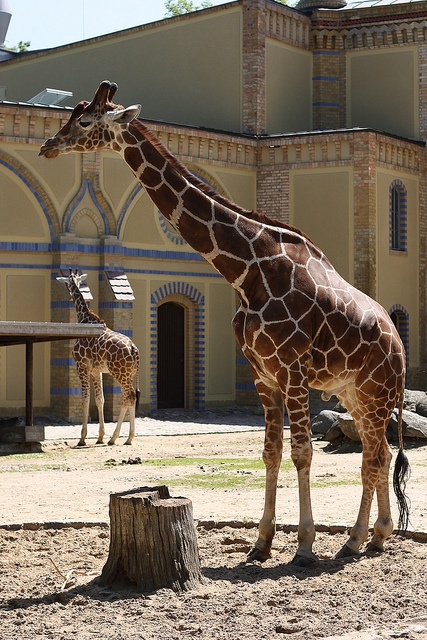Describe the objects in this image and their specific colors. I can see giraffe in darkgray, black, maroon, and gray tones and giraffe in darkgray, gray, black, and maroon tones in this image. 